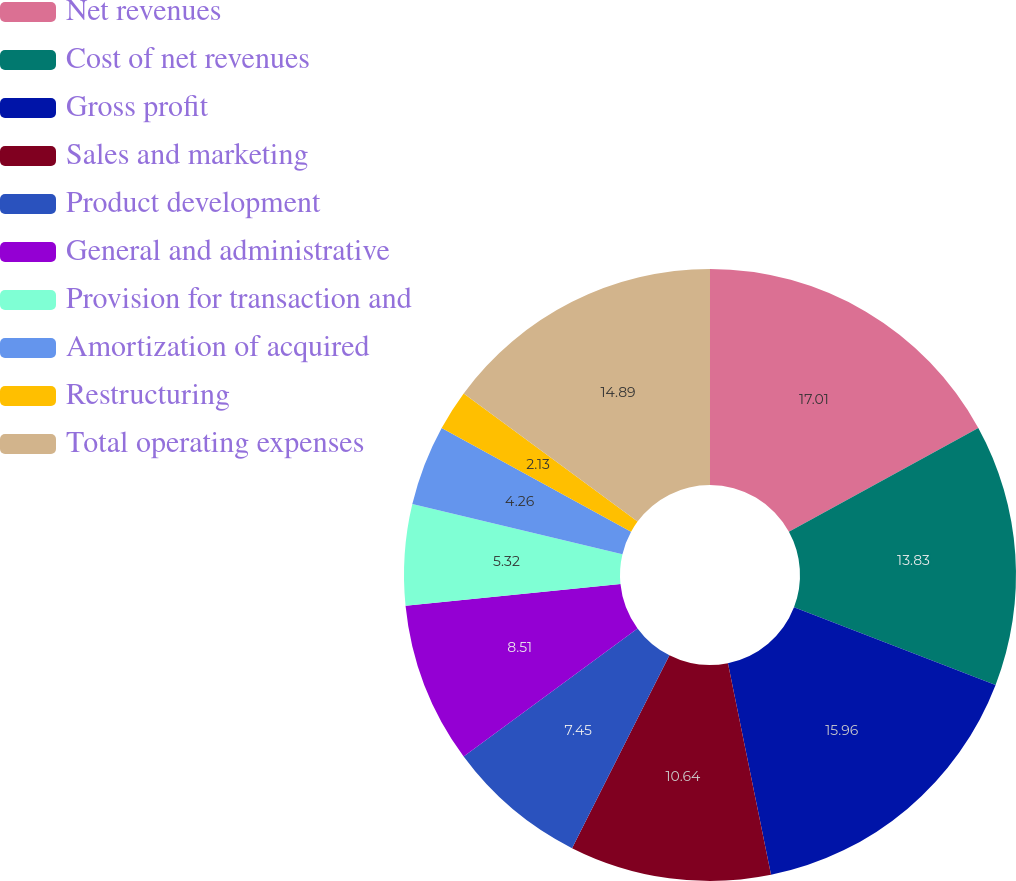Convert chart to OTSL. <chart><loc_0><loc_0><loc_500><loc_500><pie_chart><fcel>Net revenues<fcel>Cost of net revenues<fcel>Gross profit<fcel>Sales and marketing<fcel>Product development<fcel>General and administrative<fcel>Provision for transaction and<fcel>Amortization of acquired<fcel>Restructuring<fcel>Total operating expenses<nl><fcel>17.02%<fcel>13.83%<fcel>15.96%<fcel>10.64%<fcel>7.45%<fcel>8.51%<fcel>5.32%<fcel>4.26%<fcel>2.13%<fcel>14.89%<nl></chart> 